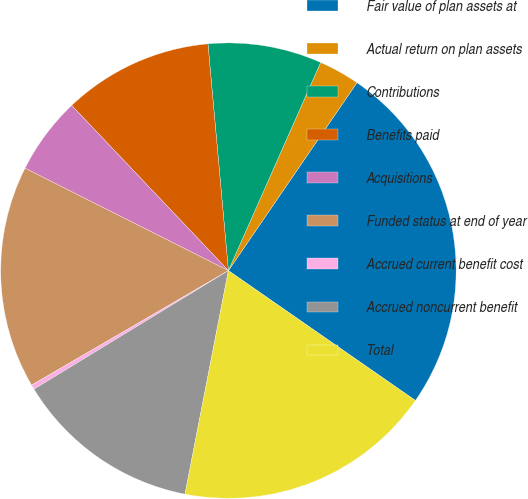<chart> <loc_0><loc_0><loc_500><loc_500><pie_chart><fcel>Fair value of plan assets at<fcel>Actual return on plan assets<fcel>Contributions<fcel>Benefits paid<fcel>Acquisitions<fcel>Funded status at end of year<fcel>Accrued current benefit cost<fcel>Accrued noncurrent benefit<fcel>Total<nl><fcel>25.11%<fcel>2.91%<fcel>8.07%<fcel>10.65%<fcel>5.49%<fcel>15.81%<fcel>0.33%<fcel>13.23%<fcel>18.39%<nl></chart> 